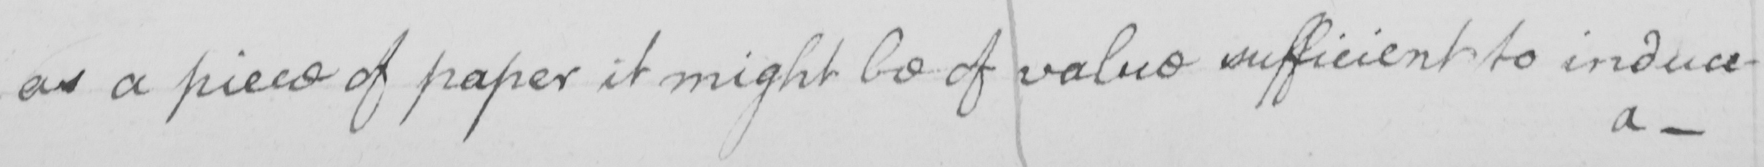What is written in this line of handwriting? as a piece of paper it might be of value sufficient to induce- 